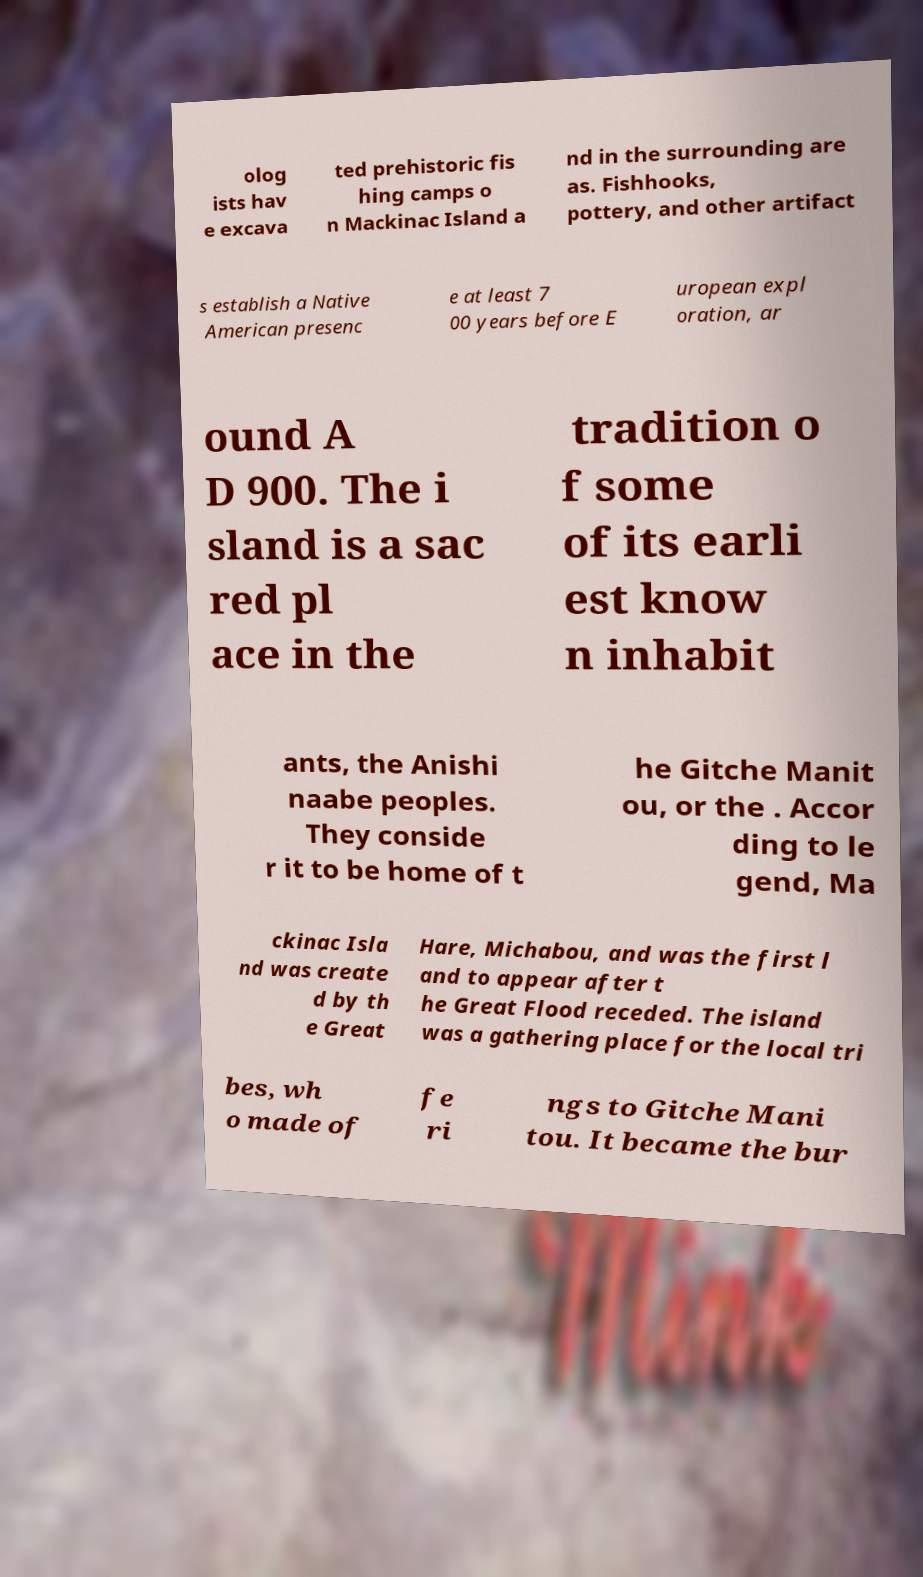Please identify and transcribe the text found in this image. olog ists hav e excava ted prehistoric fis hing camps o n Mackinac Island a nd in the surrounding are as. Fishhooks, pottery, and other artifact s establish a Native American presenc e at least 7 00 years before E uropean expl oration, ar ound A D 900. The i sland is a sac red pl ace in the tradition o f some of its earli est know n inhabit ants, the Anishi naabe peoples. They conside r it to be home of t he Gitche Manit ou, or the . Accor ding to le gend, Ma ckinac Isla nd was create d by th e Great Hare, Michabou, and was the first l and to appear after t he Great Flood receded. The island was a gathering place for the local tri bes, wh o made of fe ri ngs to Gitche Mani tou. It became the bur 